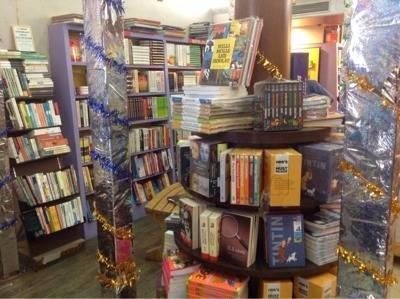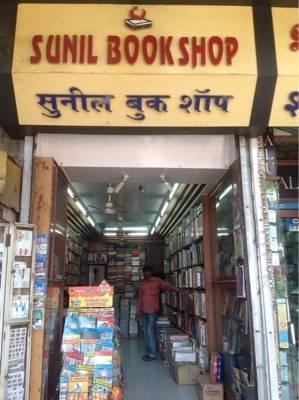The first image is the image on the left, the second image is the image on the right. For the images displayed, is the sentence "Next to at least 4 stacks of books there are two black poles painted gold towards the middle." factually correct? Answer yes or no. No. The first image is the image on the left, the second image is the image on the right. Assess this claim about the two images: "A sign with the name of the bookstore hangs over the store's entrance.". Correct or not? Answer yes or no. Yes. 